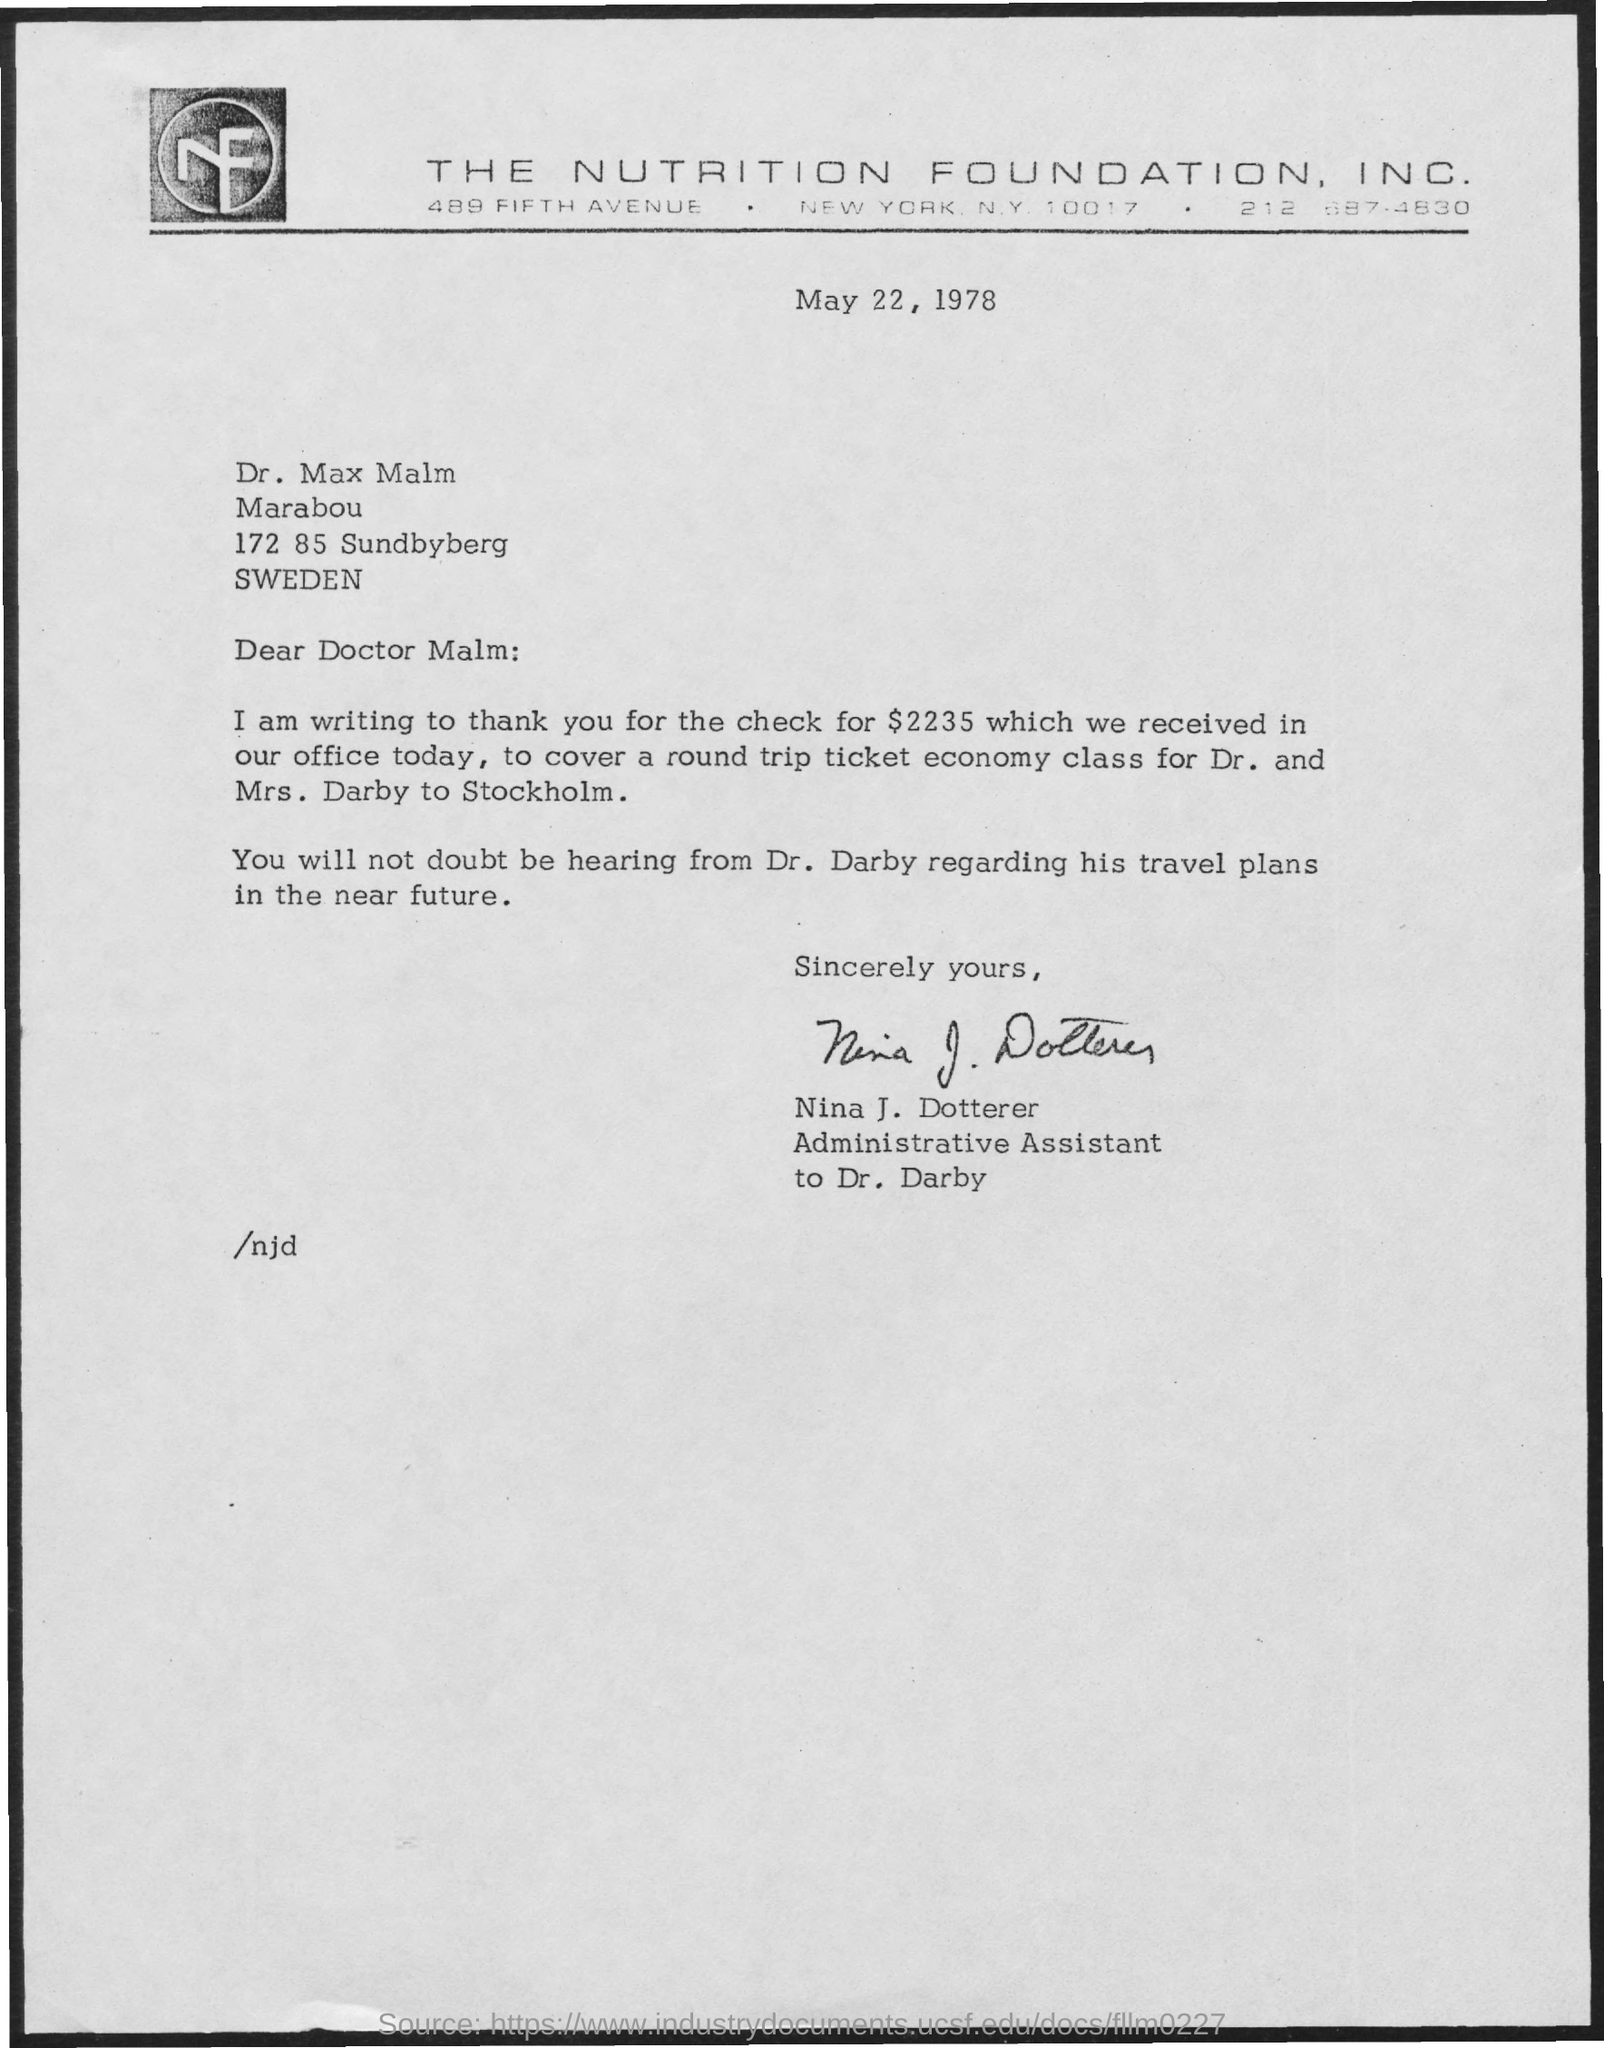Draw attention to some important aspects in this diagram. The letter has been signed by NINA J. DOTTERER. The date mentioned in this letter is May 22, 1978. The letter head mentions THE NUTRITION FOUNDATION, INC., a company that is mentioned in the letter head. 